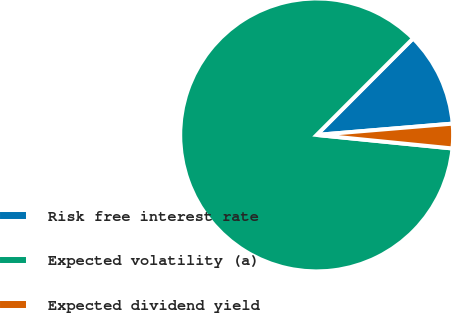Convert chart. <chart><loc_0><loc_0><loc_500><loc_500><pie_chart><fcel>Risk free interest rate<fcel>Expected volatility (a)<fcel>Expected dividend yield<nl><fcel>11.19%<fcel>85.9%<fcel>2.9%<nl></chart> 